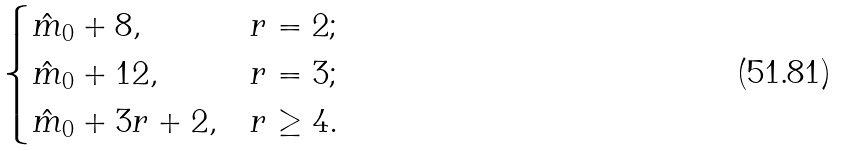Convert formula to latex. <formula><loc_0><loc_0><loc_500><loc_500>\begin{cases} \hat { m } _ { 0 } + 8 , & r = 2 ; \\ \hat { m } _ { 0 } + 1 2 , & r = 3 ; \\ \hat { m } _ { 0 } + 3 r + 2 , & r \geq 4 . \end{cases}</formula> 